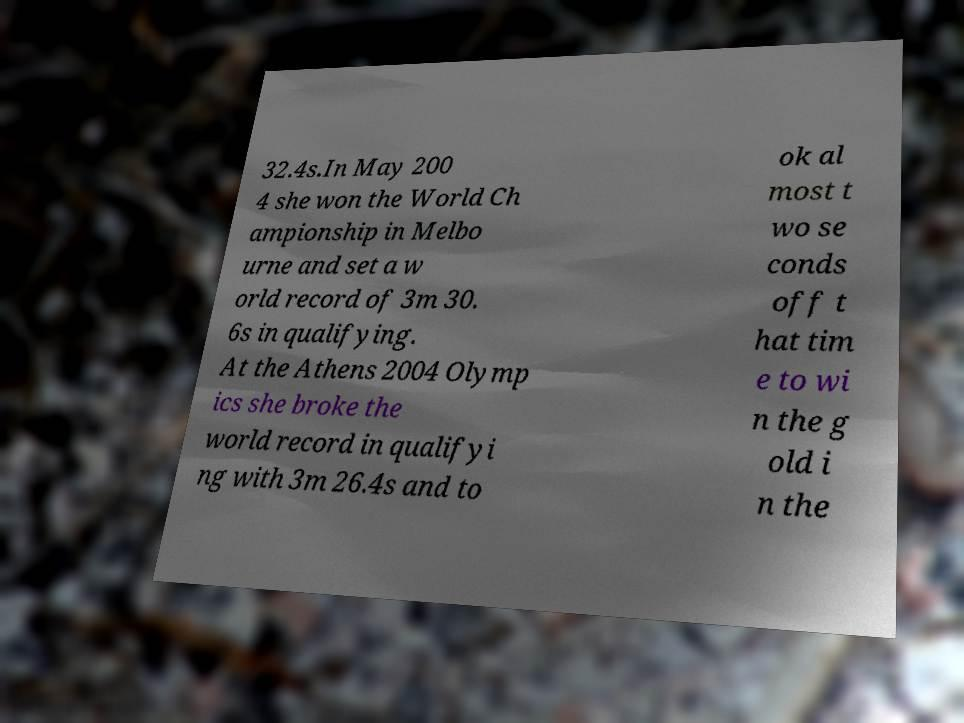Can you accurately transcribe the text from the provided image for me? 32.4s.In May 200 4 she won the World Ch ampionship in Melbo urne and set a w orld record of 3m 30. 6s in qualifying. At the Athens 2004 Olymp ics she broke the world record in qualifyi ng with 3m 26.4s and to ok al most t wo se conds off t hat tim e to wi n the g old i n the 